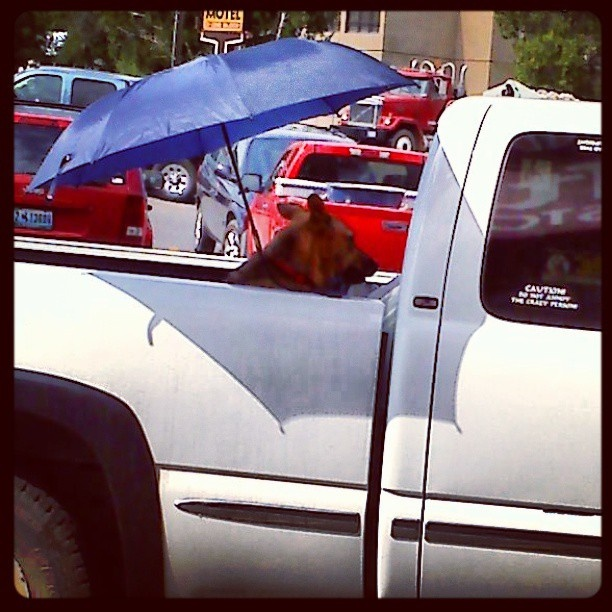Describe the objects in this image and their specific colors. I can see truck in black, white, darkgray, and gray tones, umbrella in black, darkgray, gray, blue, and navy tones, truck in black, brown, red, and lavender tones, car in black, brown, red, and lavender tones, and car in black, maroon, brown, and navy tones in this image. 